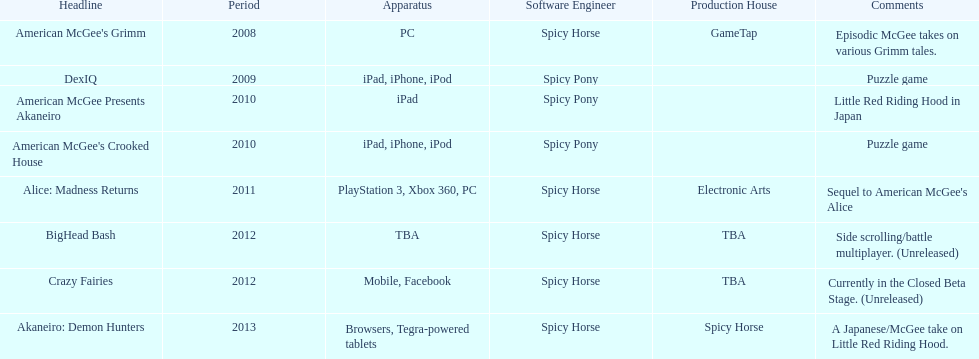Which title is for ipad but not for iphone or ipod? American McGee Presents Akaneiro. 